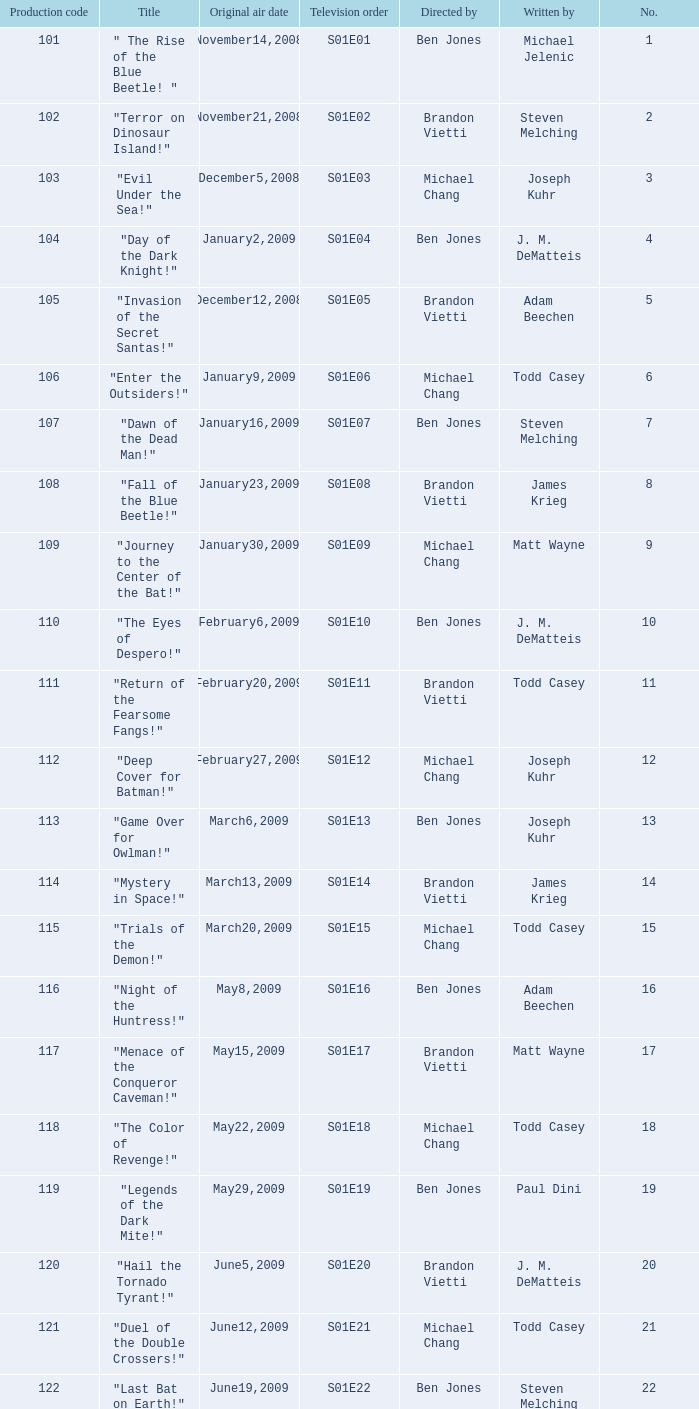Who wrote s01e06 Todd Casey. 